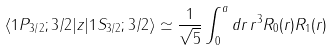<formula> <loc_0><loc_0><loc_500><loc_500>\langle 1 P _ { 3 / 2 } ; 3 / 2 | z | 1 S _ { 3 / 2 } ; 3 / 2 \rangle \simeq \frac { 1 } { \sqrt { 5 } } \int _ { 0 } ^ { a } d r \, r ^ { 3 } R _ { 0 } ( r ) R _ { 1 } ( r )</formula> 